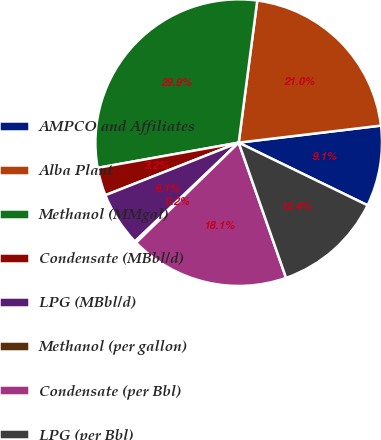Convert chart to OTSL. <chart><loc_0><loc_0><loc_500><loc_500><pie_chart><fcel>AMPCO and Affiliates<fcel>Alba Plant<fcel>Methanol (MMgal)<fcel>Condensate (MBbl/d)<fcel>LPG (MBbl/d)<fcel>Methanol (per gallon)<fcel>Condensate (per Bbl)<fcel>LPG (per Bbl)<nl><fcel>9.1%<fcel>21.03%<fcel>29.88%<fcel>3.16%<fcel>6.13%<fcel>0.19%<fcel>18.06%<fcel>12.43%<nl></chart> 